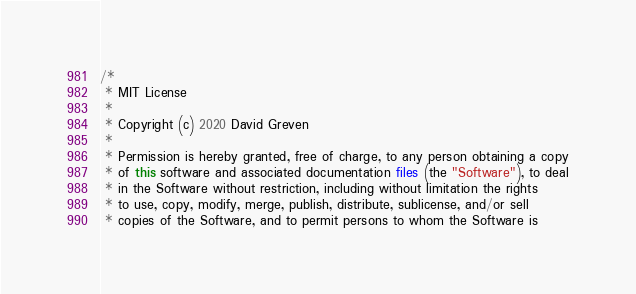<code> <loc_0><loc_0><loc_500><loc_500><_Java_>/*
 * MIT License
 *
 * Copyright (c) 2020 David Greven
 *
 * Permission is hereby granted, free of charge, to any person obtaining a copy
 * of this software and associated documentation files (the "Software"), to deal
 * in the Software without restriction, including without limitation the rights
 * to use, copy, modify, merge, publish, distribute, sublicense, and/or sell
 * copies of the Software, and to permit persons to whom the Software is</code> 